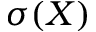Convert formula to latex. <formula><loc_0><loc_0><loc_500><loc_500>\sigma ( X )</formula> 